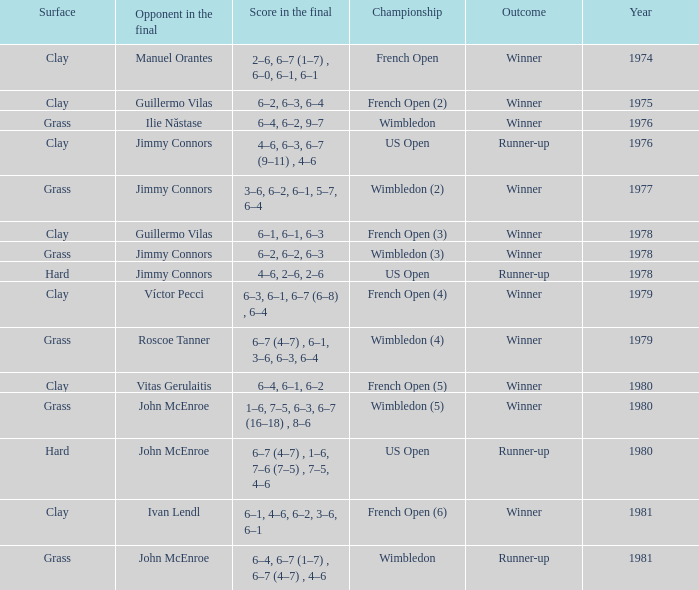What is every year where opponent in the final is John Mcenroe at Wimbledon? 1981.0. 